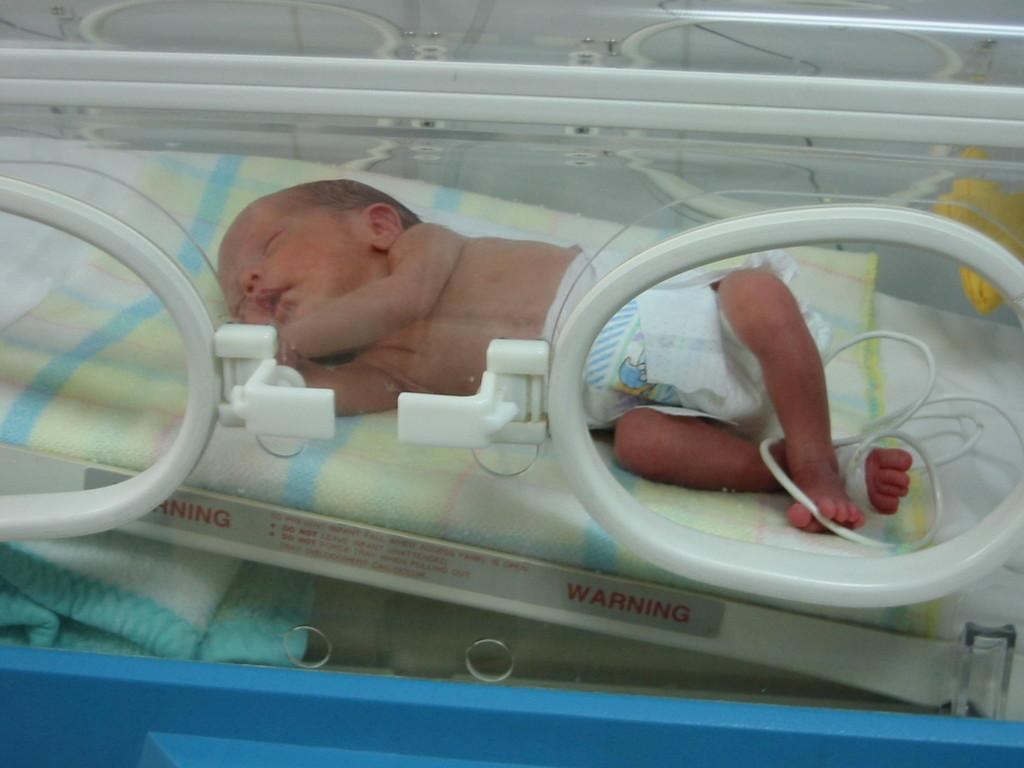What is the main subject of the image? The main subject of the image is a baby inside an intensive care. Is there any text or writing in the image? Yes, there is something written in the image. What else can be seen in the image besides the baby and the writing? There is a cloth and a wire near the baby in the image. What type of needle is being used by the creator of the baby in the image? There is no needle or creator of the baby present in the image, as it is a photograph of a real baby in an intensive care unit. What is located at the top of the image? The facts provided do not specify any objects or details at the top of the image, so it cannot be determined from the information given. 